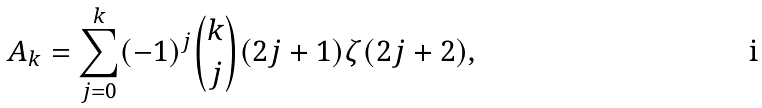Convert formula to latex. <formula><loc_0><loc_0><loc_500><loc_500>A _ { k } = \sum _ { j = 0 } ^ { k } ( - 1 ) ^ { j } { k \choose j } ( 2 j + 1 ) \zeta ( 2 j + 2 ) ,</formula> 